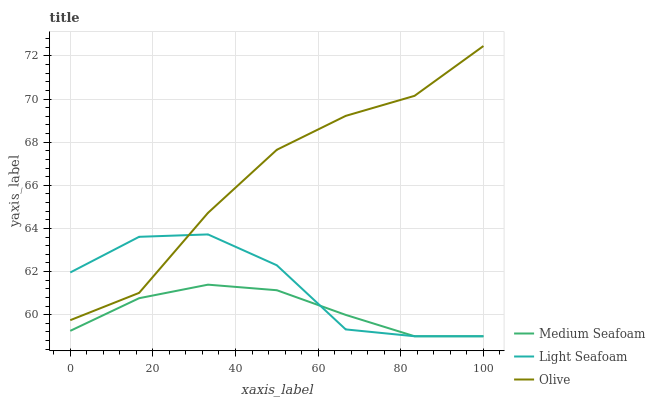Does Medium Seafoam have the minimum area under the curve?
Answer yes or no. Yes. Does Olive have the maximum area under the curve?
Answer yes or no. Yes. Does Light Seafoam have the minimum area under the curve?
Answer yes or no. No. Does Light Seafoam have the maximum area under the curve?
Answer yes or no. No. Is Medium Seafoam the smoothest?
Answer yes or no. Yes. Is Light Seafoam the roughest?
Answer yes or no. Yes. Is Light Seafoam the smoothest?
Answer yes or no. No. Is Medium Seafoam the roughest?
Answer yes or no. No. Does Light Seafoam have the lowest value?
Answer yes or no. Yes. Does Olive have the highest value?
Answer yes or no. Yes. Does Light Seafoam have the highest value?
Answer yes or no. No. Is Medium Seafoam less than Olive?
Answer yes or no. Yes. Is Olive greater than Medium Seafoam?
Answer yes or no. Yes. Does Olive intersect Light Seafoam?
Answer yes or no. Yes. Is Olive less than Light Seafoam?
Answer yes or no. No. Is Olive greater than Light Seafoam?
Answer yes or no. No. Does Medium Seafoam intersect Olive?
Answer yes or no. No. 